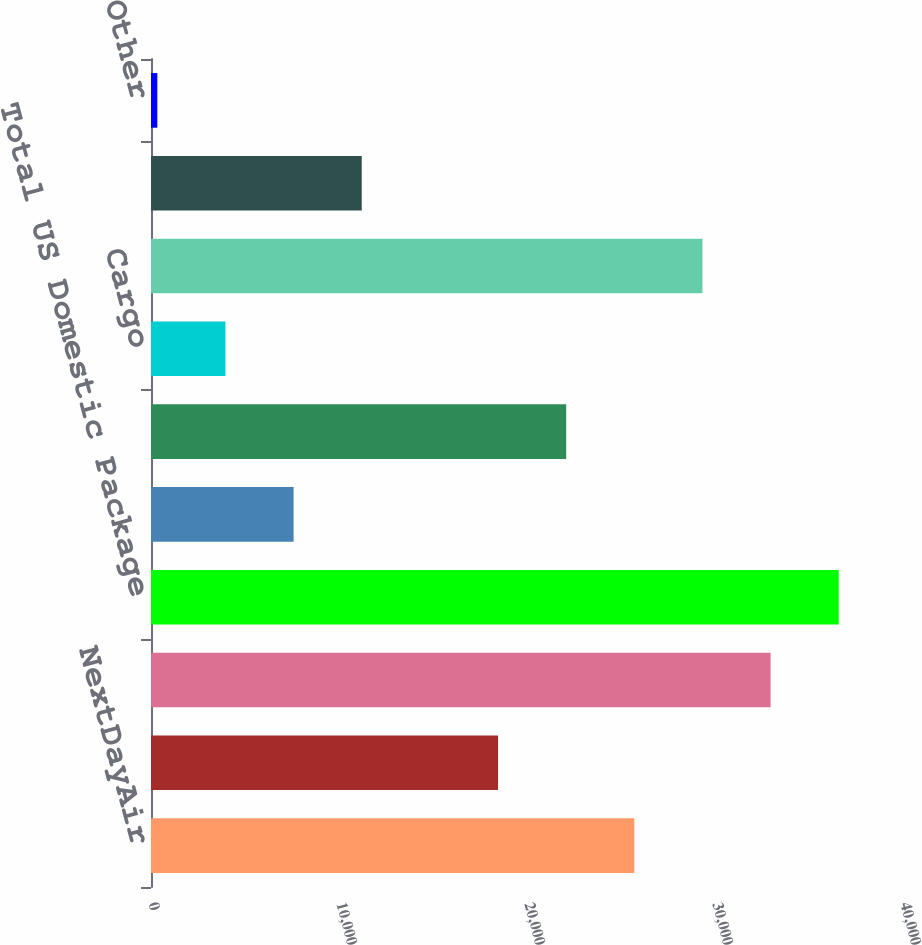<chart> <loc_0><loc_0><loc_500><loc_500><bar_chart><fcel>NextDayAir<fcel>Deferred<fcel>Ground<fcel>Total US Domestic Package<fcel>Domestic<fcel>Export<fcel>Cargo<fcel>Total International Package<fcel>Forwarding and Logistics<fcel>Other<nl><fcel>25708.5<fcel>18459.5<fcel>32957.5<fcel>36582<fcel>7586<fcel>22084<fcel>3961.5<fcel>29333<fcel>11210.5<fcel>337<nl></chart> 